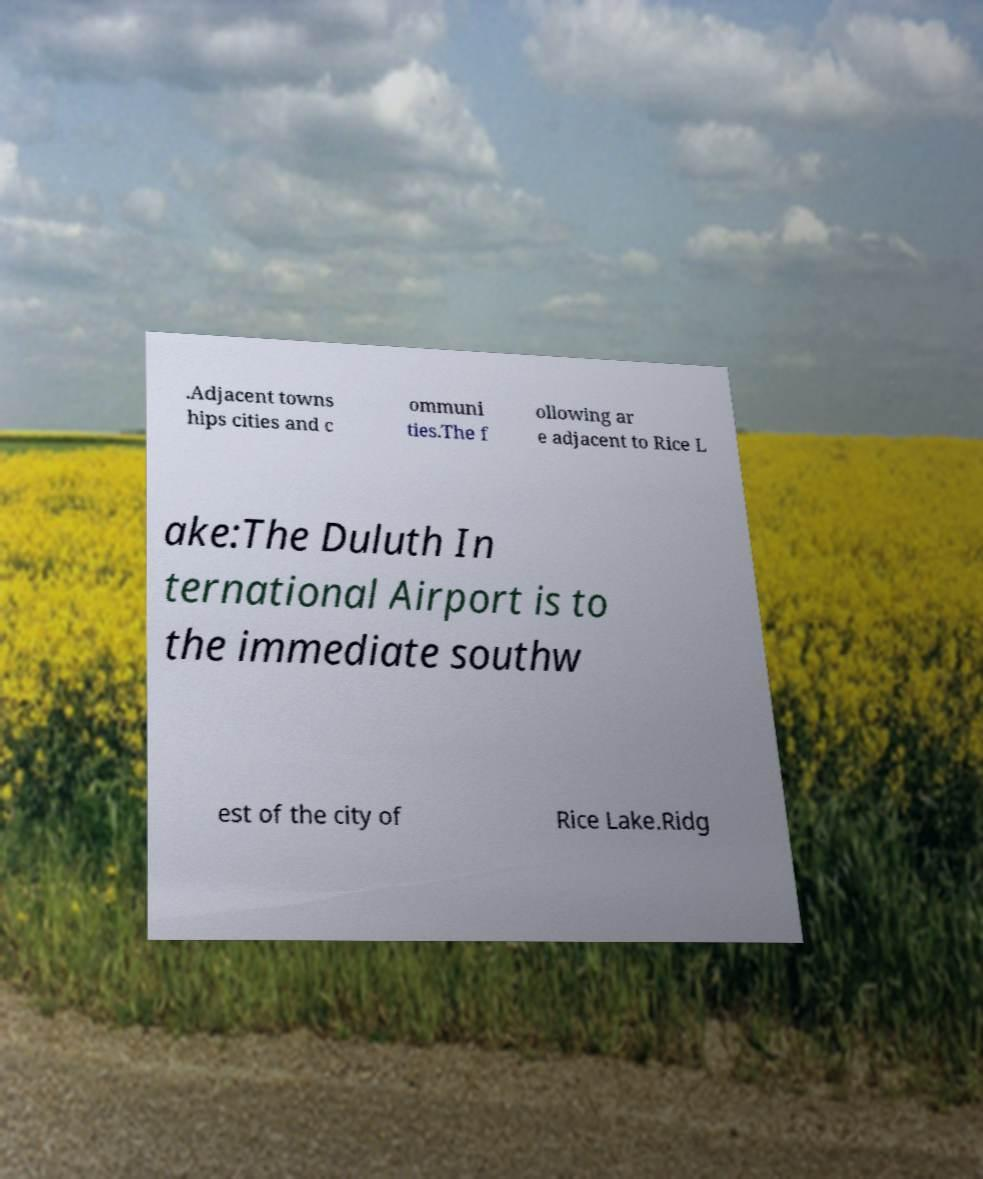I need the written content from this picture converted into text. Can you do that? .Adjacent towns hips cities and c ommuni ties.The f ollowing ar e adjacent to Rice L ake:The Duluth In ternational Airport is to the immediate southw est of the city of Rice Lake.Ridg 